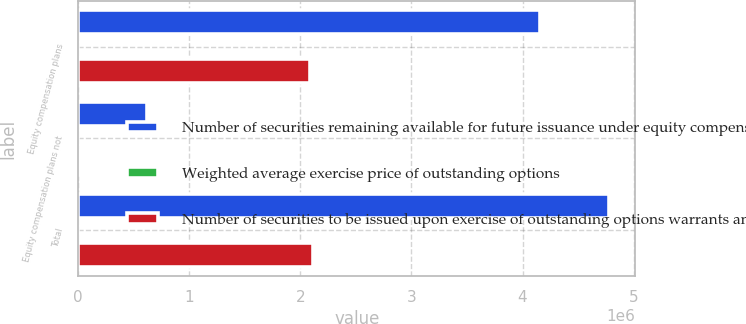<chart> <loc_0><loc_0><loc_500><loc_500><stacked_bar_chart><ecel><fcel>Equity compensation plans<fcel>Equity compensation plans not<fcel>Total<nl><fcel>Number of securities remaining available for future issuance under equity compensation plans excluding securities reflected in column a<fcel>4.15507e+06<fcel>620144<fcel>4.77522e+06<nl><fcel>Weighted average exercise price of outstanding options<fcel>329.65<fcel>415.77<fcel>340.83<nl><fcel>Number of securities to be issued upon exercise of outstanding options warrants and rights a<fcel>2.09032e+06<fcel>20392<fcel>2.11071e+06<nl></chart> 